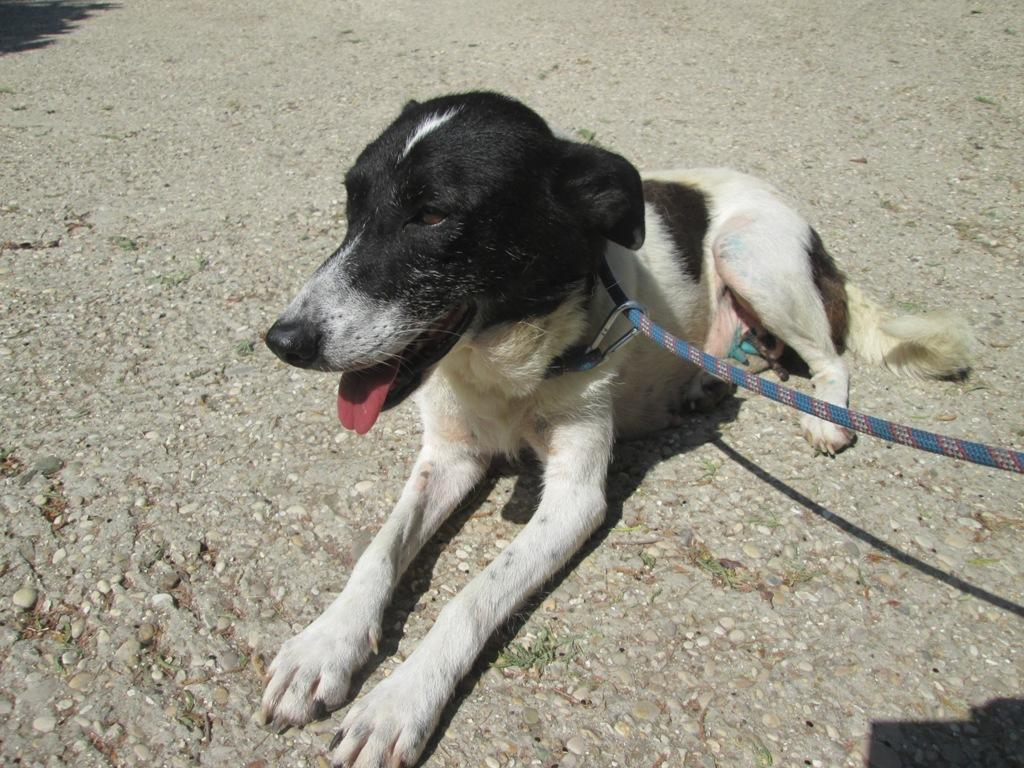What animal is present in the image? There is a dog in the image. What position is the dog in? The dog is sitting on the ground. Is there any accessory or item of clothing on the dog? Yes, the dog is wearing a belt. What type of thunder can be heard in the image? There is no thunder present in the image, as it is a still image and not an audio recording. What unit of measurement is the dog using to measure its surroundings in the image? The image does not provide information about the dog's use of any unit of measurement. 